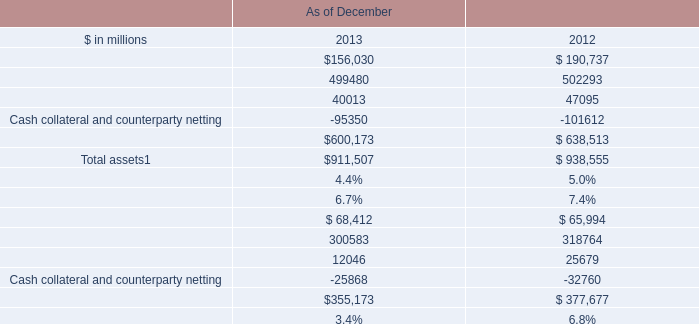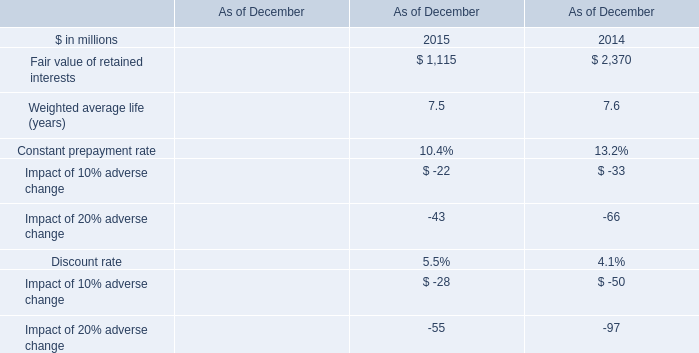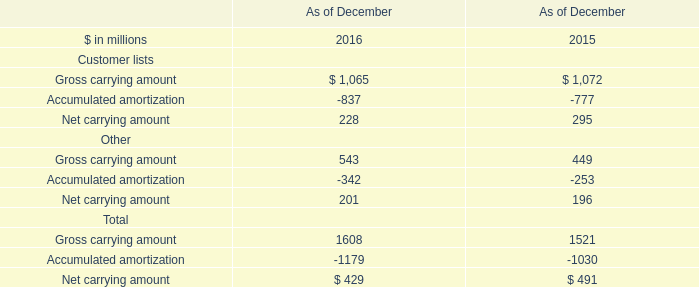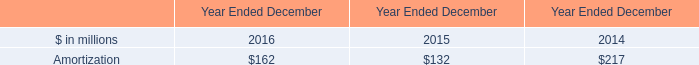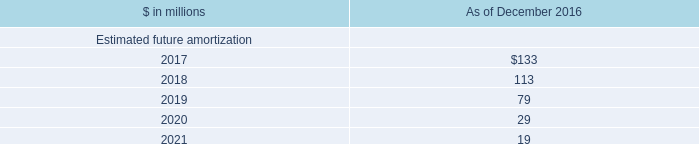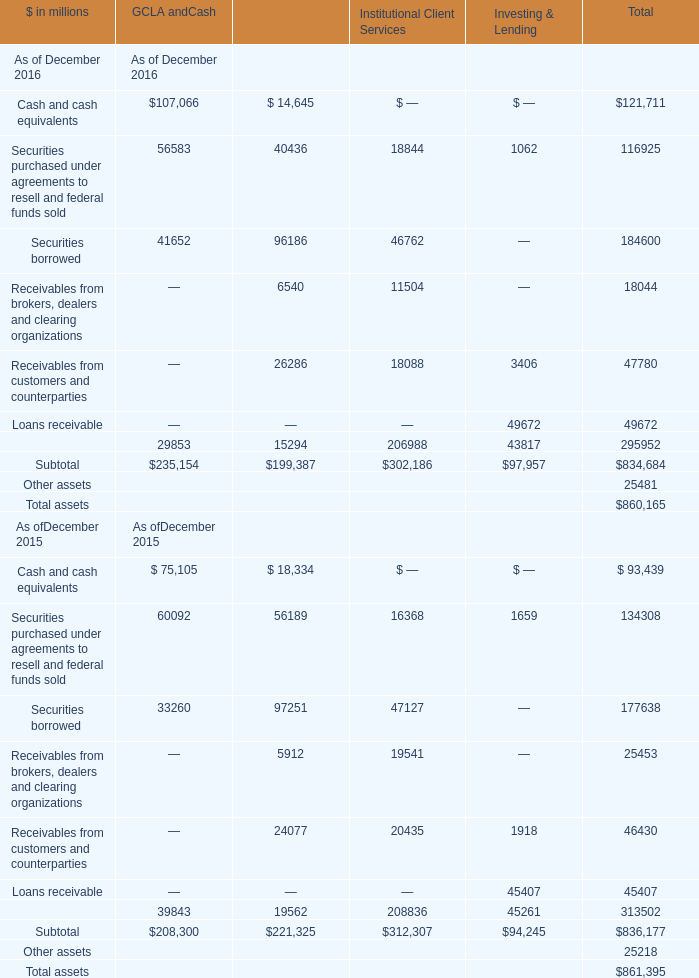What's the sum of Cash collateral and counterparty netting of As of December 2012, Securities borrowed of GCLA andCash As of December 2016, and Receivables from brokers, dealers and clearing organizations of Secured Client Financing ? 
Computations: ((32760.0 + 41652.0) + 6540.0)
Answer: 80952.0. 